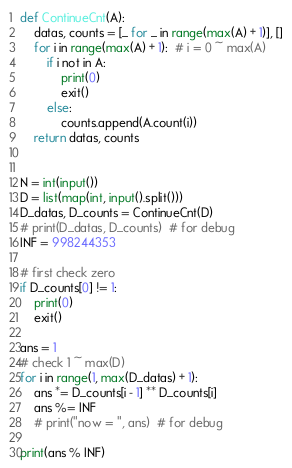<code> <loc_0><loc_0><loc_500><loc_500><_Python_>def ContinueCnt(A):
    datas, counts = [_ for _ in range(max(A) + 1)], []
    for i in range(max(A) + 1):  # i = 0 ~ max(A)
        if i not in A:
            print(0)
            exit()
        else:
            counts.append(A.count(i))
    return datas, counts


N = int(input())
D = list(map(int, input().split()))
D_datas, D_counts = ContinueCnt(D)
# print(D_datas, D_counts)  # for debug
INF = 998244353

# first check zero
if D_counts[0] != 1:
    print(0)
    exit()

ans = 1
# check 1 ~ max(D)
for i in range(1, max(D_datas) + 1):
    ans *= D_counts[i - 1] ** D_counts[i]
    ans %= INF
    # print("now = ", ans)  # for debug

print(ans % INF)
</code> 